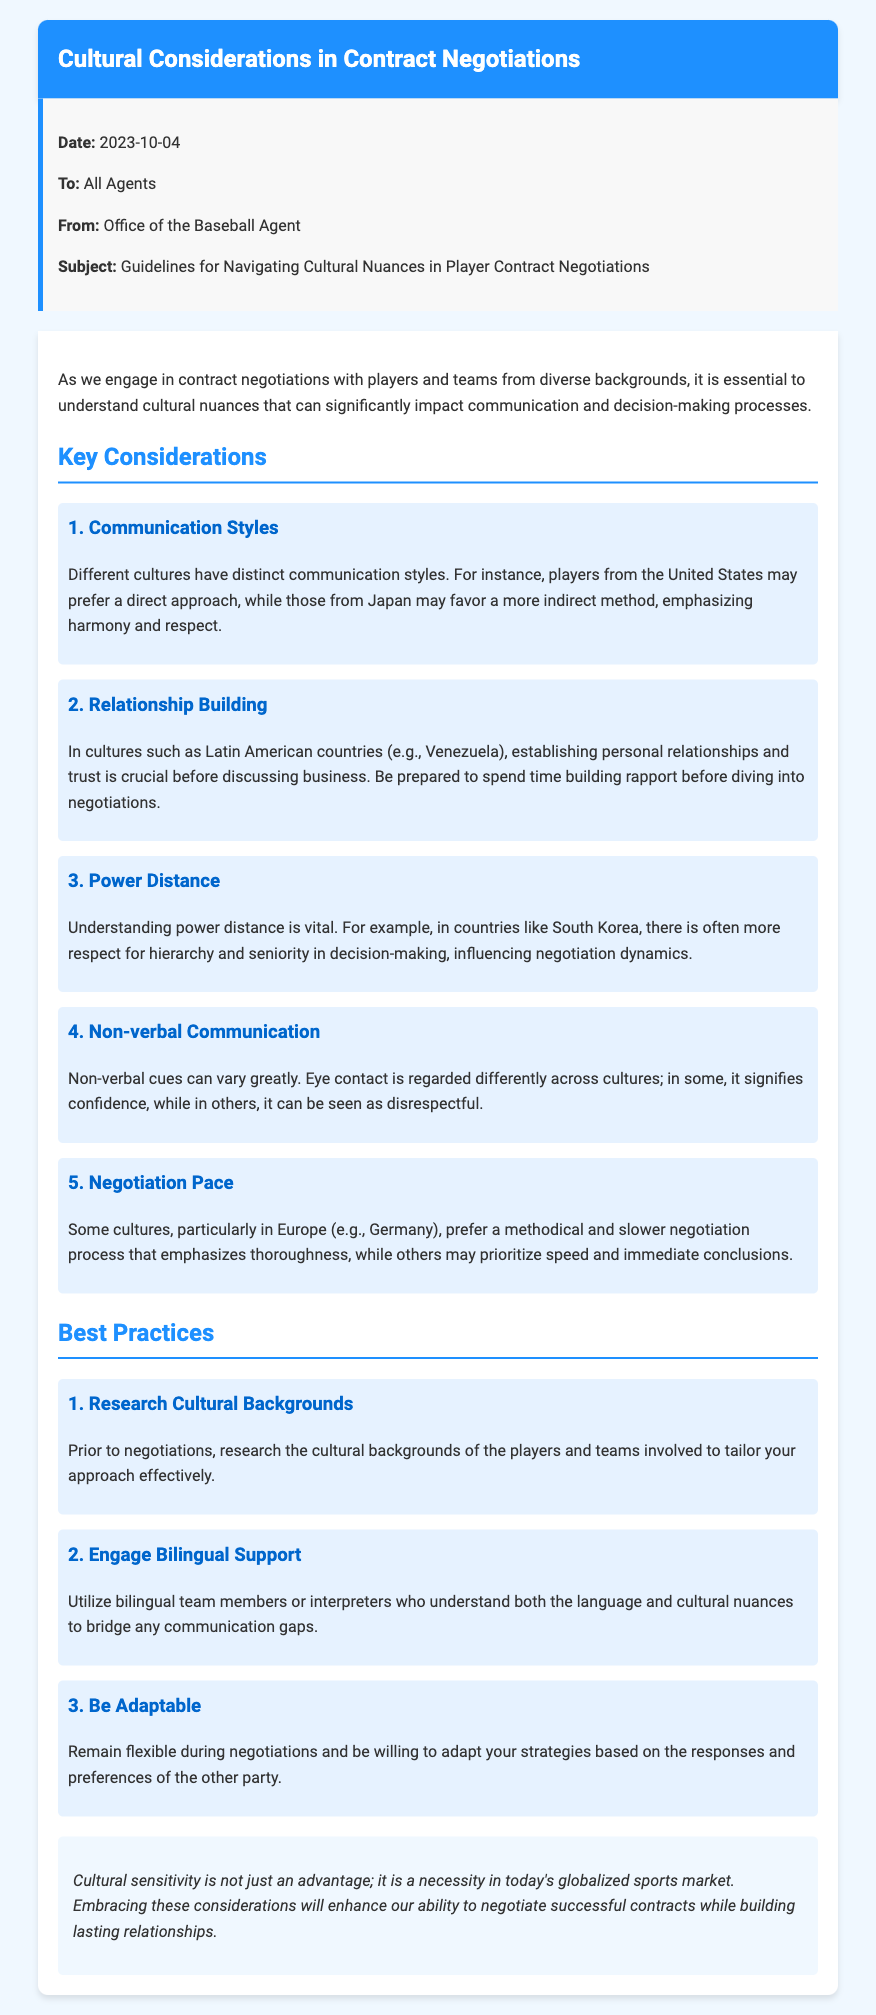What is the date of the memo? The date of the memo is mentioned in the memo details section.
Answer: 2023-10-04 Who is the memo addressed to? The recipient of the memo is specified in the memo details section.
Answer: All Agents What is the subject of the memo? The subject is outlined clearly in the memo details section.
Answer: Guidelines for Navigating Cultural Nuances in Player Contract Negotiations How many key considerations are listed in the memo? The document provides a numbered list of the key considerations.
Answer: 5 Which culture emphasizes personal relationships before business? The document mentions specific cultures that focus on relationship building.
Answer: Latin American In which country is there a higher respect for hierarchy in negotiations? The document specifies countries with varying power distance views.
Answer: South Korea What style of communication do players from the United States prefer? The memo describes different communication styles based on cultural backgrounds.
Answer: Direct What should agents do prior to negotiations according to best practices? The best practices section provides recommendations for agents before negotiations.
Answer: Research cultural backgrounds What is highlighted as a necessity in today’s globalized sports market? The conclusion summarizes the importance of cultural considerations during negotiations.
Answer: Cultural sensitivity 